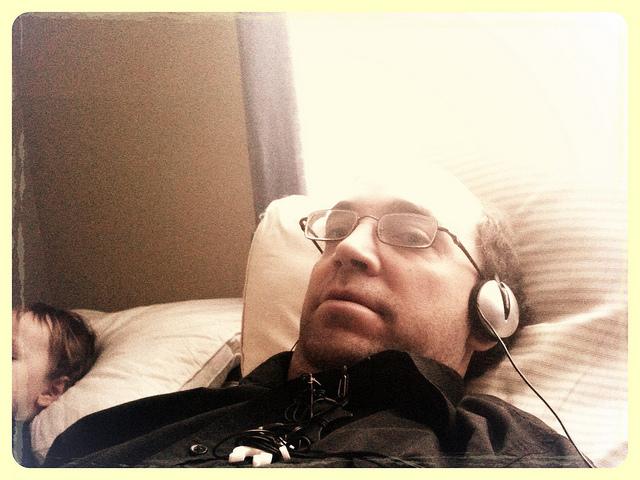Does the person have any facial hair?
Answer briefly. Yes. Is there a child visible?
Keep it brief. Yes. What is in his ears?
Answer briefly. Headphones. 